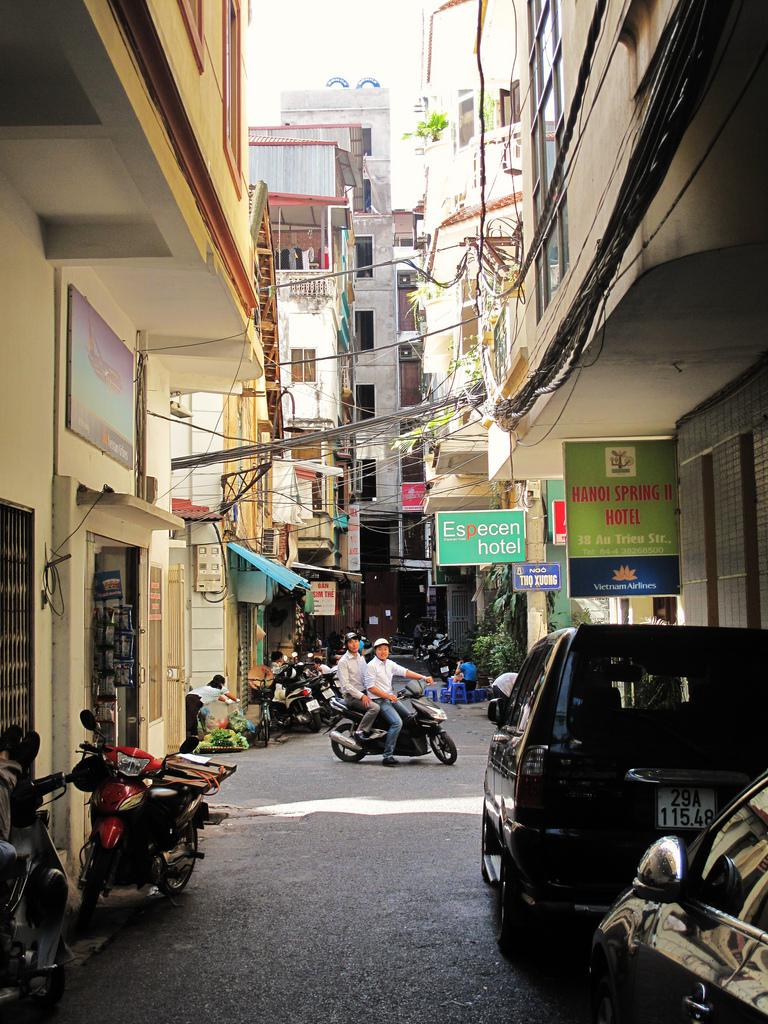Question: how many bikes are parked?
Choices:
A. Three.
B. Four.
C. Two.
D. Five.
Answer with the letter. Answer: C Question: who has a white shirt on?
Choices:
A. The groom.
B. Flower in lapel.
C. A person on the left.
D. Bride has bouquet.
Answer with the letter. Answer: C Question: what kind of scene is this?
Choices:
A. Fishing pole in holder.
B. Cork bobbing in river.
C. An outdoor scene.
D. Boat drifting by.
Answer with the letter. Answer: C Question: what has white lettering on the right side?
Choices:
A. A small blue sign.
B. Open for business.
C. Hanging on a doorknob.
D. Open at 10:00 am.
Answer with the letter. Answer: A Question: what says Especen Hotel?
Choices:
A. Hanoi Vietnam.
B. Luxury rooms.
C. A green sign.
D. Near railway.
Answer with the letter. Answer: C Question: what are the two gentlemen riding on?
Choices:
A. Motorcycle.
B. Bicycle.
C. Lawn mower.
D. Horse.
Answer with the letter. Answer: A Question: when was the picture taken?
Choices:
A. Night.
B. Morning.
C. Day.
D. Evening.
Answer with the letter. Answer: C Question: who is riding on the motorcycle?
Choices:
A. One man.
B. Two men.
C. Two women.
D. One woman.
Answer with the letter. Answer: B Question: where are they located?
Choices:
A. Back alley.
B. Behind the building.
C. Outside the back door.
D. Creepy alley.
Answer with the letter. Answer: A Question: what cross the buildings?
Choices:
A. Cable TV cables to the apartments.
B. Passageways above the street for tenets.
C. Telephone lines.
D. Power lines.
Answer with the letter. Answer: D Question: where are there many buildings?
Choices:
A. In the town.
B. In the country.
C. In the distance.
D. By the seashore.
Answer with the letter. Answer: C Question: what are parked on the side of the road?
Choices:
A. Motorcycles.
B. Trucks.
C. Bicycles.
D. Vehicles.
Answer with the letter. Answer: D Question: why are they wearing helmets?
Choices:
A. To protect their eyes.
B. To protect their face.
C. To protect their chin.
D. To protect their heads.
Answer with the letter. Answer: D Question: what colors are the closest sigh?
Choices:
A. Blue and green.
B. Yellow and red.
C. White and black.
D. Purple and Red.
Answer with the letter. Answer: A Question: how many men are on the motorcycle?
Choices:
A. Three.
B. Two.
C. Four.
D. One.
Answer with the letter. Answer: B 